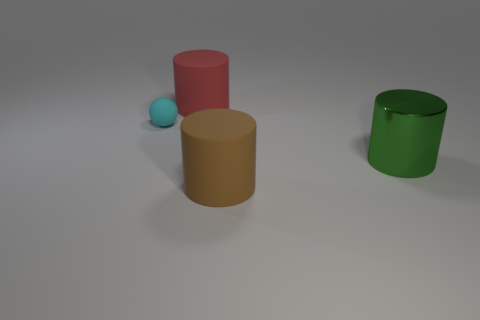Is there anything else that is the same size as the ball?
Provide a succinct answer. No. How many cyan objects are rubber spheres or tiny metal cubes?
Provide a succinct answer. 1. There is a rubber object that is both behind the green shiny thing and in front of the big red object; what is its color?
Provide a succinct answer. Cyan. Do the large thing behind the green metal object and the cylinder in front of the big green cylinder have the same material?
Provide a short and direct response. Yes. Are there more red matte cylinders on the left side of the big brown rubber object than red rubber things that are to the left of the red thing?
Offer a terse response. Yes. There is a brown matte object that is the same size as the red object; what is its shape?
Your response must be concise. Cylinder. How many objects are large yellow cylinders or cylinders in front of the green cylinder?
Your response must be concise. 1. How many metal objects are left of the tiny matte object?
Provide a succinct answer. 0. There is a small thing that is made of the same material as the large brown thing; what is its color?
Provide a short and direct response. Cyan. How many metal things are either big cyan things or red objects?
Offer a terse response. 0. 